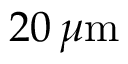<formula> <loc_0><loc_0><loc_500><loc_500>2 0 \, \mu \mathrm m</formula> 